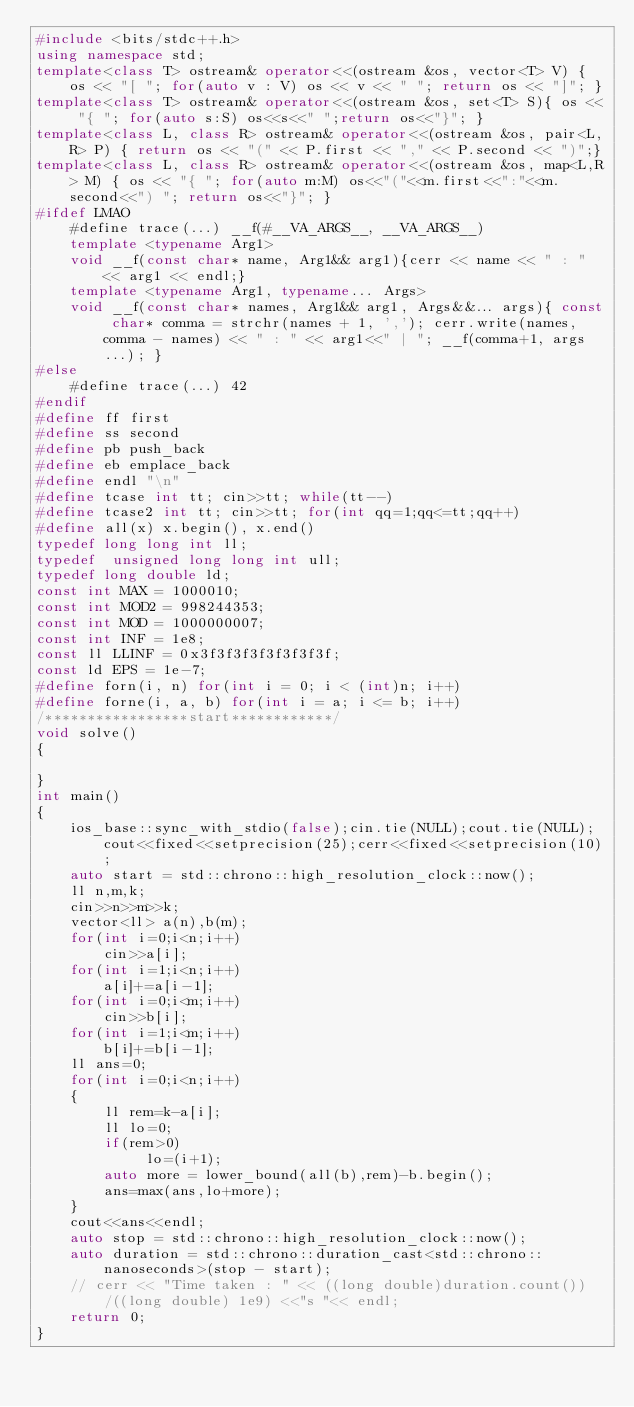<code> <loc_0><loc_0><loc_500><loc_500><_C++_>#include <bits/stdc++.h>
using namespace std;
template<class T> ostream& operator<<(ostream &os, vector<T> V) { os << "[ "; for(auto v : V) os << v << " "; return os << "]"; }
template<class T> ostream& operator<<(ostream &os, set<T> S){ os << "{ "; for(auto s:S) os<<s<<" ";return os<<"}"; }
template<class L, class R> ostream& operator<<(ostream &os, pair<L,R> P) { return os << "(" << P.first << "," << P.second << ")";}
template<class L, class R> ostream& operator<<(ostream &os, map<L,R> M) { os << "{ "; for(auto m:M) os<<"("<<m.first<<":"<<m.second<<") "; return os<<"}"; }
#ifdef LMAO
    #define trace(...) __f(#__VA_ARGS__, __VA_ARGS__)
    template <typename Arg1>
    void __f(const char* name, Arg1&& arg1){cerr << name << " : " << arg1 << endl;}
    template <typename Arg1, typename... Args>
    void __f(const char* names, Arg1&& arg1, Args&&... args){ const char* comma = strchr(names + 1, ','); cerr.write(names, comma - names) << " : " << arg1<<" | "; __f(comma+1, args...); }
#else
    #define trace(...) 42
#endif
#define ff first
#define ss second
#define pb push_back
#define eb emplace_back
#define endl "\n"
#define tcase int tt; cin>>tt; while(tt--)
#define tcase2 int tt; cin>>tt; for(int qq=1;qq<=tt;qq++)
#define all(x) x.begin(), x.end()
typedef long long int ll;
typedef  unsigned long long int ull;
typedef long double ld;
const int MAX = 1000010;
const int MOD2 = 998244353;
const int MOD = 1000000007; 
const int INF = 1e8;    
const ll LLINF = 0x3f3f3f3f3f3f3f3f;
const ld EPS = 1e-7;
#define forn(i, n) for(int i = 0; i < (int)n; i++)
#define forne(i, a, b) for(int i = a; i <= b; i++)   
/*****************start************/
void solve()
{

}
int main()
{
    ios_base::sync_with_stdio(false);cin.tie(NULL);cout.tie(NULL);cout<<fixed<<setprecision(25);cerr<<fixed<<setprecision(10);
    auto start = std::chrono::high_resolution_clock::now();
    ll n,m,k;
    cin>>n>>m>>k;
    vector<ll> a(n),b(m);
    for(int i=0;i<n;i++)
        cin>>a[i];
    for(int i=1;i<n;i++)   
        a[i]+=a[i-1];
    for(int i=0;i<m;i++)
        cin>>b[i];
    for(int i=1;i<m;i++)
        b[i]+=b[i-1];
    ll ans=0;
    for(int i=0;i<n;i++)
    {
        ll rem=k-a[i];
        ll lo=0;
        if(rem>0)
             lo=(i+1);
        auto more = lower_bound(all(b),rem)-b.begin();
        ans=max(ans,lo+more);
    }
    cout<<ans<<endl;
    auto stop = std::chrono::high_resolution_clock::now(); 
    auto duration = std::chrono::duration_cast<std::chrono::nanoseconds>(stop - start); 
    // cerr << "Time taken : " << ((long double)duration.count())/((long double) 1e9) <<"s "<< endl;     
    return 0;
}
</code> 